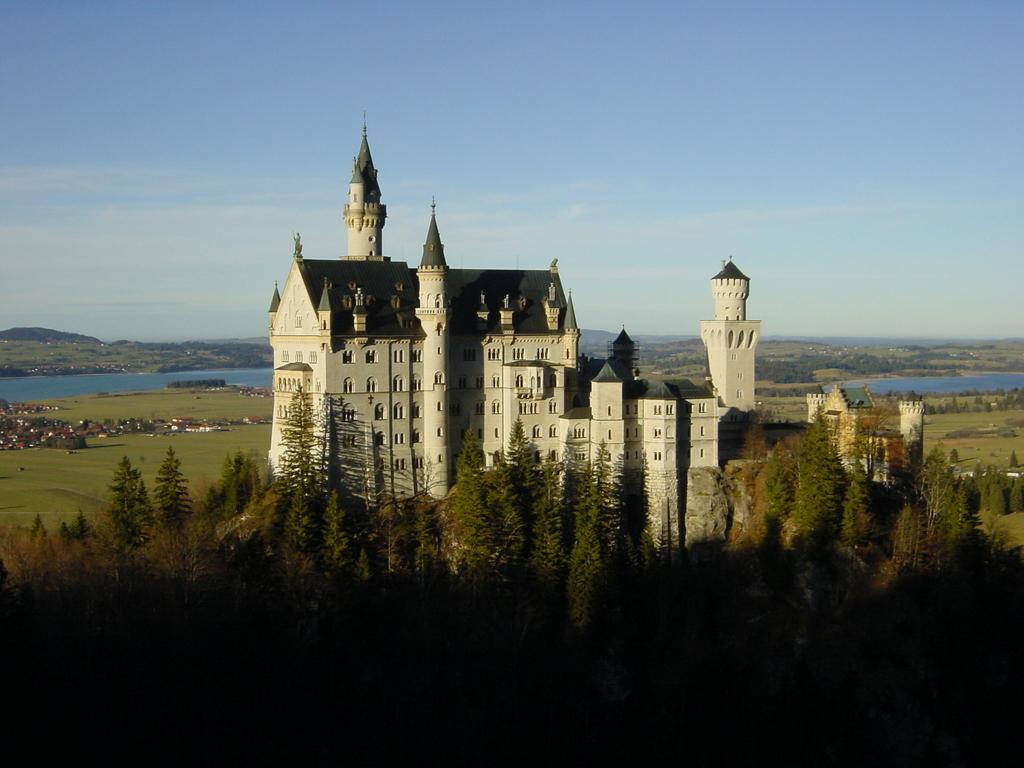What type of structure is present in the image? There is a building in the image. Can you describe the color of the building? The building is white. What other natural elements can be seen in the image? There are trees in the image. What is the color of the trees? The trees are green. What can be seen in the background of the image? There is water visible in the background of the image. How would you describe the sky in the image? The sky is blue and white. What type of operation is being performed by the doctor in the image? There is no doctor or operation present in the image. What is being served for lunch in the image? There is no lunch or food present in the image. 